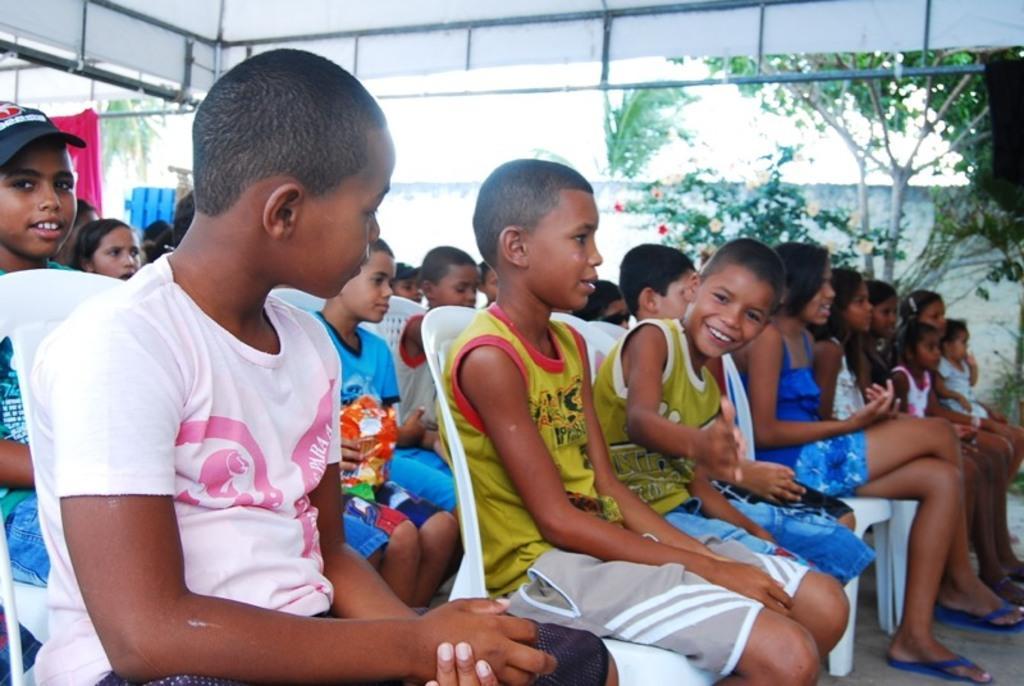Describe this image in one or two sentences. In this image we can see group of children sitting on chairs placed on floor. In the background ,we can see group of trees ,plants ,shed and sky. 